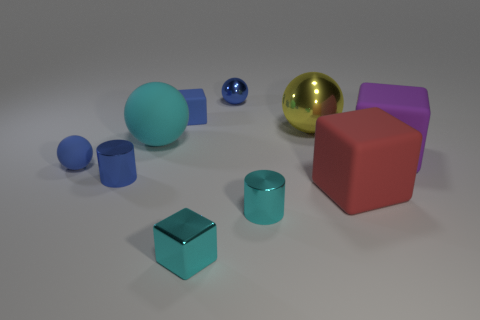Subtract all balls. How many objects are left? 6 Add 6 big yellow shiny balls. How many big yellow shiny balls exist? 7 Subtract 0 yellow cylinders. How many objects are left? 10 Subtract all small gray shiny things. Subtract all cyan matte spheres. How many objects are left? 9 Add 4 blue metallic cylinders. How many blue metallic cylinders are left? 5 